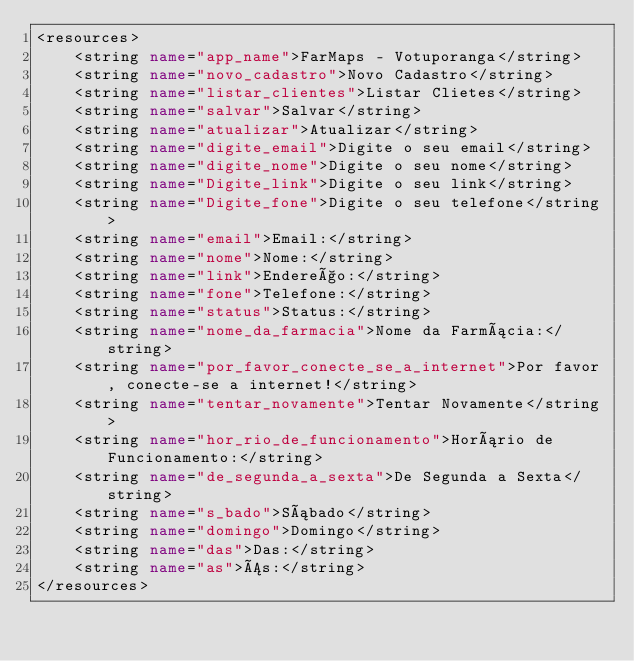Convert code to text. <code><loc_0><loc_0><loc_500><loc_500><_XML_><resources>
    <string name="app_name">FarMaps - Votuporanga</string>
    <string name="novo_cadastro">Novo Cadastro</string>
    <string name="listar_clientes">Listar Clietes</string>
    <string name="salvar">Salvar</string>
    <string name="atualizar">Atualizar</string>
    <string name="digite_email">Digite o seu email</string>
    <string name="digite_nome">Digite o seu nome</string>
    <string name="Digite_link">Digite o seu link</string>
    <string name="Digite_fone">Digite o seu telefone</string>
    <string name="email">Email:</string>
    <string name="nome">Nome:</string>
    <string name="link">Endereço:</string>
    <string name="fone">Telefone:</string>
    <string name="status">Status:</string>
    <string name="nome_da_farmacia">Nome da Farmácia:</string>
    <string name="por_favor_conecte_se_a_internet">Por favor, conecte-se a internet!</string>
    <string name="tentar_novamente">Tentar Novamente</string>
    <string name="hor_rio_de_funcionamento">Horário de Funcionamento:</string>
    <string name="de_segunda_a_sexta">De Segunda a Sexta</string>
    <string name="s_bado">Sábado</string>
    <string name="domingo">Domingo</string>
    <string name="das">Das:</string>
    <string name="as">Ás:</string>
</resources>
</code> 